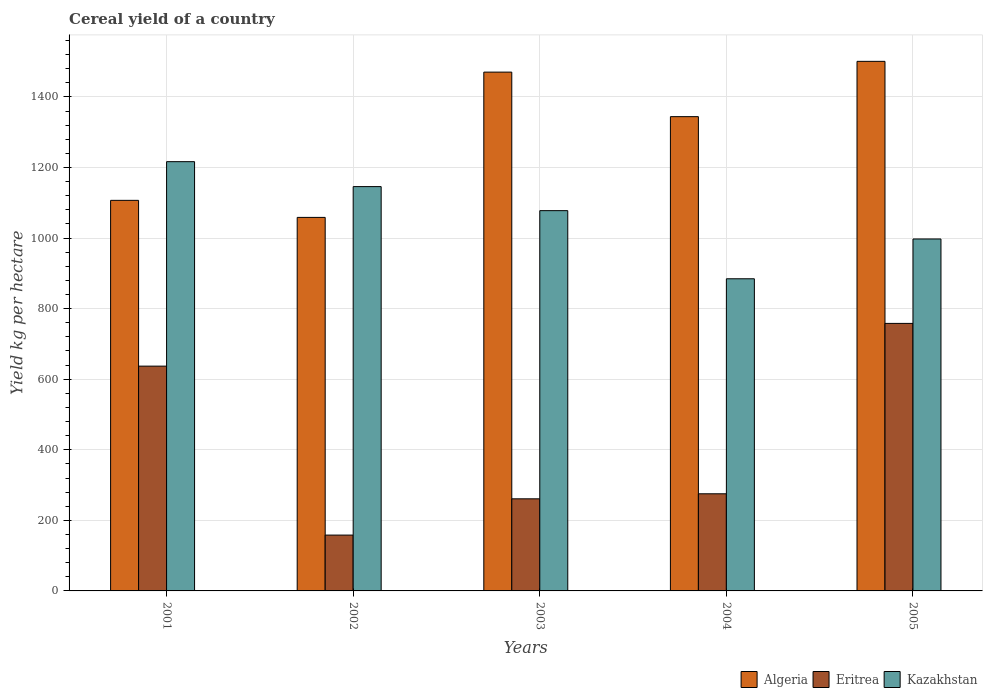How many different coloured bars are there?
Your answer should be very brief. 3. How many groups of bars are there?
Your answer should be compact. 5. Are the number of bars per tick equal to the number of legend labels?
Offer a terse response. Yes. Are the number of bars on each tick of the X-axis equal?
Offer a terse response. Yes. How many bars are there on the 4th tick from the left?
Provide a succinct answer. 3. How many bars are there on the 4th tick from the right?
Give a very brief answer. 3. What is the total cereal yield in Kazakhstan in 2001?
Ensure brevity in your answer.  1216.57. Across all years, what is the maximum total cereal yield in Eritrea?
Your response must be concise. 758.2. Across all years, what is the minimum total cereal yield in Algeria?
Your answer should be very brief. 1058.62. What is the total total cereal yield in Kazakhstan in the graph?
Keep it short and to the point. 5322.3. What is the difference between the total cereal yield in Algeria in 2002 and that in 2004?
Offer a terse response. -285.51. What is the difference between the total cereal yield in Kazakhstan in 2005 and the total cereal yield in Algeria in 2002?
Offer a terse response. -61.16. What is the average total cereal yield in Kazakhstan per year?
Provide a short and direct response. 1064.46. In the year 2004, what is the difference between the total cereal yield in Algeria and total cereal yield in Kazakhstan?
Ensure brevity in your answer.  459.47. What is the ratio of the total cereal yield in Kazakhstan in 2001 to that in 2004?
Offer a terse response. 1.38. Is the difference between the total cereal yield in Algeria in 2002 and 2003 greater than the difference between the total cereal yield in Kazakhstan in 2002 and 2003?
Keep it short and to the point. No. What is the difference between the highest and the second highest total cereal yield in Kazakhstan?
Ensure brevity in your answer.  70.68. What is the difference between the highest and the lowest total cereal yield in Algeria?
Offer a very short reply. 442.24. In how many years, is the total cereal yield in Kazakhstan greater than the average total cereal yield in Kazakhstan taken over all years?
Ensure brevity in your answer.  3. Is the sum of the total cereal yield in Eritrea in 2003 and 2004 greater than the maximum total cereal yield in Kazakhstan across all years?
Make the answer very short. No. What does the 2nd bar from the left in 2003 represents?
Provide a succinct answer. Eritrea. What does the 1st bar from the right in 2001 represents?
Your answer should be compact. Kazakhstan. Is it the case that in every year, the sum of the total cereal yield in Kazakhstan and total cereal yield in Eritrea is greater than the total cereal yield in Algeria?
Ensure brevity in your answer.  No. Are all the bars in the graph horizontal?
Give a very brief answer. No. How many years are there in the graph?
Your response must be concise. 5. Does the graph contain grids?
Keep it short and to the point. Yes. Where does the legend appear in the graph?
Ensure brevity in your answer.  Bottom right. How are the legend labels stacked?
Offer a terse response. Horizontal. What is the title of the graph?
Provide a succinct answer. Cereal yield of a country. What is the label or title of the X-axis?
Your answer should be compact. Years. What is the label or title of the Y-axis?
Offer a very short reply. Yield kg per hectare. What is the Yield kg per hectare in Algeria in 2001?
Give a very brief answer. 1106.92. What is the Yield kg per hectare in Eritrea in 2001?
Make the answer very short. 637.09. What is the Yield kg per hectare in Kazakhstan in 2001?
Keep it short and to the point. 1216.57. What is the Yield kg per hectare of Algeria in 2002?
Your response must be concise. 1058.62. What is the Yield kg per hectare of Eritrea in 2002?
Give a very brief answer. 158.23. What is the Yield kg per hectare of Kazakhstan in 2002?
Offer a terse response. 1145.89. What is the Yield kg per hectare of Algeria in 2003?
Provide a short and direct response. 1470.34. What is the Yield kg per hectare of Eritrea in 2003?
Ensure brevity in your answer.  261.04. What is the Yield kg per hectare in Kazakhstan in 2003?
Provide a succinct answer. 1077.73. What is the Yield kg per hectare of Algeria in 2004?
Offer a terse response. 1344.12. What is the Yield kg per hectare of Eritrea in 2004?
Offer a very short reply. 275.29. What is the Yield kg per hectare in Kazakhstan in 2004?
Offer a terse response. 884.65. What is the Yield kg per hectare of Algeria in 2005?
Offer a terse response. 1500.85. What is the Yield kg per hectare of Eritrea in 2005?
Offer a terse response. 758.2. What is the Yield kg per hectare of Kazakhstan in 2005?
Your answer should be compact. 997.45. Across all years, what is the maximum Yield kg per hectare of Algeria?
Offer a very short reply. 1500.85. Across all years, what is the maximum Yield kg per hectare in Eritrea?
Offer a terse response. 758.2. Across all years, what is the maximum Yield kg per hectare in Kazakhstan?
Keep it short and to the point. 1216.57. Across all years, what is the minimum Yield kg per hectare in Algeria?
Make the answer very short. 1058.62. Across all years, what is the minimum Yield kg per hectare in Eritrea?
Offer a terse response. 158.23. Across all years, what is the minimum Yield kg per hectare of Kazakhstan?
Ensure brevity in your answer.  884.65. What is the total Yield kg per hectare of Algeria in the graph?
Offer a very short reply. 6480.85. What is the total Yield kg per hectare in Eritrea in the graph?
Your answer should be very brief. 2089.84. What is the total Yield kg per hectare in Kazakhstan in the graph?
Your answer should be very brief. 5322.3. What is the difference between the Yield kg per hectare in Algeria in 2001 and that in 2002?
Offer a very short reply. 48.3. What is the difference between the Yield kg per hectare in Eritrea in 2001 and that in 2002?
Make the answer very short. 478.86. What is the difference between the Yield kg per hectare in Kazakhstan in 2001 and that in 2002?
Offer a very short reply. 70.68. What is the difference between the Yield kg per hectare in Algeria in 2001 and that in 2003?
Your response must be concise. -363.43. What is the difference between the Yield kg per hectare in Eritrea in 2001 and that in 2003?
Your response must be concise. 376.05. What is the difference between the Yield kg per hectare in Kazakhstan in 2001 and that in 2003?
Provide a short and direct response. 138.84. What is the difference between the Yield kg per hectare in Algeria in 2001 and that in 2004?
Your answer should be very brief. -237.21. What is the difference between the Yield kg per hectare of Eritrea in 2001 and that in 2004?
Make the answer very short. 361.8. What is the difference between the Yield kg per hectare in Kazakhstan in 2001 and that in 2004?
Your answer should be very brief. 331.92. What is the difference between the Yield kg per hectare in Algeria in 2001 and that in 2005?
Your response must be concise. -393.94. What is the difference between the Yield kg per hectare of Eritrea in 2001 and that in 2005?
Offer a very short reply. -121.11. What is the difference between the Yield kg per hectare in Kazakhstan in 2001 and that in 2005?
Offer a terse response. 219.12. What is the difference between the Yield kg per hectare in Algeria in 2002 and that in 2003?
Your answer should be compact. -411.73. What is the difference between the Yield kg per hectare of Eritrea in 2002 and that in 2003?
Your answer should be very brief. -102.81. What is the difference between the Yield kg per hectare in Kazakhstan in 2002 and that in 2003?
Your answer should be compact. 68.16. What is the difference between the Yield kg per hectare in Algeria in 2002 and that in 2004?
Your response must be concise. -285.51. What is the difference between the Yield kg per hectare of Eritrea in 2002 and that in 2004?
Your answer should be compact. -117.06. What is the difference between the Yield kg per hectare in Kazakhstan in 2002 and that in 2004?
Offer a very short reply. 261.23. What is the difference between the Yield kg per hectare in Algeria in 2002 and that in 2005?
Provide a succinct answer. -442.24. What is the difference between the Yield kg per hectare of Eritrea in 2002 and that in 2005?
Ensure brevity in your answer.  -599.97. What is the difference between the Yield kg per hectare in Kazakhstan in 2002 and that in 2005?
Ensure brevity in your answer.  148.44. What is the difference between the Yield kg per hectare of Algeria in 2003 and that in 2004?
Your answer should be very brief. 126.22. What is the difference between the Yield kg per hectare in Eritrea in 2003 and that in 2004?
Offer a very short reply. -14.25. What is the difference between the Yield kg per hectare in Kazakhstan in 2003 and that in 2004?
Your response must be concise. 193.08. What is the difference between the Yield kg per hectare in Algeria in 2003 and that in 2005?
Ensure brevity in your answer.  -30.51. What is the difference between the Yield kg per hectare in Eritrea in 2003 and that in 2005?
Your answer should be very brief. -497.16. What is the difference between the Yield kg per hectare of Kazakhstan in 2003 and that in 2005?
Keep it short and to the point. 80.28. What is the difference between the Yield kg per hectare in Algeria in 2004 and that in 2005?
Your response must be concise. -156.73. What is the difference between the Yield kg per hectare of Eritrea in 2004 and that in 2005?
Your answer should be compact. -482.91. What is the difference between the Yield kg per hectare of Kazakhstan in 2004 and that in 2005?
Keep it short and to the point. -112.8. What is the difference between the Yield kg per hectare of Algeria in 2001 and the Yield kg per hectare of Eritrea in 2002?
Provide a short and direct response. 948.69. What is the difference between the Yield kg per hectare in Algeria in 2001 and the Yield kg per hectare in Kazakhstan in 2002?
Your answer should be compact. -38.97. What is the difference between the Yield kg per hectare of Eritrea in 2001 and the Yield kg per hectare of Kazakhstan in 2002?
Offer a very short reply. -508.8. What is the difference between the Yield kg per hectare of Algeria in 2001 and the Yield kg per hectare of Eritrea in 2003?
Your response must be concise. 845.88. What is the difference between the Yield kg per hectare in Algeria in 2001 and the Yield kg per hectare in Kazakhstan in 2003?
Give a very brief answer. 29.18. What is the difference between the Yield kg per hectare of Eritrea in 2001 and the Yield kg per hectare of Kazakhstan in 2003?
Make the answer very short. -440.64. What is the difference between the Yield kg per hectare in Algeria in 2001 and the Yield kg per hectare in Eritrea in 2004?
Make the answer very short. 831.63. What is the difference between the Yield kg per hectare of Algeria in 2001 and the Yield kg per hectare of Kazakhstan in 2004?
Ensure brevity in your answer.  222.26. What is the difference between the Yield kg per hectare in Eritrea in 2001 and the Yield kg per hectare in Kazakhstan in 2004?
Your answer should be very brief. -247.56. What is the difference between the Yield kg per hectare of Algeria in 2001 and the Yield kg per hectare of Eritrea in 2005?
Make the answer very short. 348.72. What is the difference between the Yield kg per hectare in Algeria in 2001 and the Yield kg per hectare in Kazakhstan in 2005?
Offer a very short reply. 109.46. What is the difference between the Yield kg per hectare of Eritrea in 2001 and the Yield kg per hectare of Kazakhstan in 2005?
Make the answer very short. -360.36. What is the difference between the Yield kg per hectare in Algeria in 2002 and the Yield kg per hectare in Eritrea in 2003?
Provide a succinct answer. 797.58. What is the difference between the Yield kg per hectare in Algeria in 2002 and the Yield kg per hectare in Kazakhstan in 2003?
Your answer should be compact. -19.11. What is the difference between the Yield kg per hectare in Eritrea in 2002 and the Yield kg per hectare in Kazakhstan in 2003?
Keep it short and to the point. -919.5. What is the difference between the Yield kg per hectare of Algeria in 2002 and the Yield kg per hectare of Eritrea in 2004?
Keep it short and to the point. 783.33. What is the difference between the Yield kg per hectare of Algeria in 2002 and the Yield kg per hectare of Kazakhstan in 2004?
Make the answer very short. 173.96. What is the difference between the Yield kg per hectare of Eritrea in 2002 and the Yield kg per hectare of Kazakhstan in 2004?
Keep it short and to the point. -726.42. What is the difference between the Yield kg per hectare of Algeria in 2002 and the Yield kg per hectare of Eritrea in 2005?
Keep it short and to the point. 300.42. What is the difference between the Yield kg per hectare of Algeria in 2002 and the Yield kg per hectare of Kazakhstan in 2005?
Give a very brief answer. 61.16. What is the difference between the Yield kg per hectare in Eritrea in 2002 and the Yield kg per hectare in Kazakhstan in 2005?
Your response must be concise. -839.22. What is the difference between the Yield kg per hectare in Algeria in 2003 and the Yield kg per hectare in Eritrea in 2004?
Give a very brief answer. 1195.05. What is the difference between the Yield kg per hectare in Algeria in 2003 and the Yield kg per hectare in Kazakhstan in 2004?
Keep it short and to the point. 585.69. What is the difference between the Yield kg per hectare in Eritrea in 2003 and the Yield kg per hectare in Kazakhstan in 2004?
Ensure brevity in your answer.  -623.62. What is the difference between the Yield kg per hectare in Algeria in 2003 and the Yield kg per hectare in Eritrea in 2005?
Your response must be concise. 712.15. What is the difference between the Yield kg per hectare of Algeria in 2003 and the Yield kg per hectare of Kazakhstan in 2005?
Provide a succinct answer. 472.89. What is the difference between the Yield kg per hectare in Eritrea in 2003 and the Yield kg per hectare in Kazakhstan in 2005?
Your answer should be compact. -736.42. What is the difference between the Yield kg per hectare of Algeria in 2004 and the Yield kg per hectare of Eritrea in 2005?
Keep it short and to the point. 585.93. What is the difference between the Yield kg per hectare in Algeria in 2004 and the Yield kg per hectare in Kazakhstan in 2005?
Keep it short and to the point. 346.67. What is the difference between the Yield kg per hectare in Eritrea in 2004 and the Yield kg per hectare in Kazakhstan in 2005?
Provide a short and direct response. -722.16. What is the average Yield kg per hectare of Algeria per year?
Offer a terse response. 1296.17. What is the average Yield kg per hectare of Eritrea per year?
Ensure brevity in your answer.  417.97. What is the average Yield kg per hectare in Kazakhstan per year?
Make the answer very short. 1064.46. In the year 2001, what is the difference between the Yield kg per hectare of Algeria and Yield kg per hectare of Eritrea?
Offer a very short reply. 469.83. In the year 2001, what is the difference between the Yield kg per hectare in Algeria and Yield kg per hectare in Kazakhstan?
Provide a short and direct response. -109.66. In the year 2001, what is the difference between the Yield kg per hectare in Eritrea and Yield kg per hectare in Kazakhstan?
Keep it short and to the point. -579.48. In the year 2002, what is the difference between the Yield kg per hectare of Algeria and Yield kg per hectare of Eritrea?
Give a very brief answer. 900.39. In the year 2002, what is the difference between the Yield kg per hectare of Algeria and Yield kg per hectare of Kazakhstan?
Offer a terse response. -87.27. In the year 2002, what is the difference between the Yield kg per hectare of Eritrea and Yield kg per hectare of Kazakhstan?
Your answer should be compact. -987.66. In the year 2003, what is the difference between the Yield kg per hectare in Algeria and Yield kg per hectare in Eritrea?
Offer a terse response. 1209.31. In the year 2003, what is the difference between the Yield kg per hectare in Algeria and Yield kg per hectare in Kazakhstan?
Offer a terse response. 392.61. In the year 2003, what is the difference between the Yield kg per hectare in Eritrea and Yield kg per hectare in Kazakhstan?
Your answer should be compact. -816.7. In the year 2004, what is the difference between the Yield kg per hectare in Algeria and Yield kg per hectare in Eritrea?
Offer a terse response. 1068.83. In the year 2004, what is the difference between the Yield kg per hectare of Algeria and Yield kg per hectare of Kazakhstan?
Provide a short and direct response. 459.47. In the year 2004, what is the difference between the Yield kg per hectare of Eritrea and Yield kg per hectare of Kazakhstan?
Give a very brief answer. -609.36. In the year 2005, what is the difference between the Yield kg per hectare in Algeria and Yield kg per hectare in Eritrea?
Provide a short and direct response. 742.65. In the year 2005, what is the difference between the Yield kg per hectare of Algeria and Yield kg per hectare of Kazakhstan?
Your response must be concise. 503.4. In the year 2005, what is the difference between the Yield kg per hectare of Eritrea and Yield kg per hectare of Kazakhstan?
Your answer should be compact. -239.26. What is the ratio of the Yield kg per hectare in Algeria in 2001 to that in 2002?
Offer a very short reply. 1.05. What is the ratio of the Yield kg per hectare of Eritrea in 2001 to that in 2002?
Provide a succinct answer. 4.03. What is the ratio of the Yield kg per hectare of Kazakhstan in 2001 to that in 2002?
Give a very brief answer. 1.06. What is the ratio of the Yield kg per hectare in Algeria in 2001 to that in 2003?
Your answer should be very brief. 0.75. What is the ratio of the Yield kg per hectare of Eritrea in 2001 to that in 2003?
Make the answer very short. 2.44. What is the ratio of the Yield kg per hectare in Kazakhstan in 2001 to that in 2003?
Offer a terse response. 1.13. What is the ratio of the Yield kg per hectare of Algeria in 2001 to that in 2004?
Your answer should be very brief. 0.82. What is the ratio of the Yield kg per hectare in Eritrea in 2001 to that in 2004?
Ensure brevity in your answer.  2.31. What is the ratio of the Yield kg per hectare in Kazakhstan in 2001 to that in 2004?
Make the answer very short. 1.38. What is the ratio of the Yield kg per hectare of Algeria in 2001 to that in 2005?
Your answer should be very brief. 0.74. What is the ratio of the Yield kg per hectare of Eritrea in 2001 to that in 2005?
Keep it short and to the point. 0.84. What is the ratio of the Yield kg per hectare in Kazakhstan in 2001 to that in 2005?
Offer a very short reply. 1.22. What is the ratio of the Yield kg per hectare of Algeria in 2002 to that in 2003?
Provide a succinct answer. 0.72. What is the ratio of the Yield kg per hectare of Eritrea in 2002 to that in 2003?
Offer a terse response. 0.61. What is the ratio of the Yield kg per hectare in Kazakhstan in 2002 to that in 2003?
Offer a very short reply. 1.06. What is the ratio of the Yield kg per hectare of Algeria in 2002 to that in 2004?
Your answer should be compact. 0.79. What is the ratio of the Yield kg per hectare of Eritrea in 2002 to that in 2004?
Provide a short and direct response. 0.57. What is the ratio of the Yield kg per hectare in Kazakhstan in 2002 to that in 2004?
Offer a terse response. 1.3. What is the ratio of the Yield kg per hectare of Algeria in 2002 to that in 2005?
Ensure brevity in your answer.  0.71. What is the ratio of the Yield kg per hectare in Eritrea in 2002 to that in 2005?
Offer a very short reply. 0.21. What is the ratio of the Yield kg per hectare in Kazakhstan in 2002 to that in 2005?
Give a very brief answer. 1.15. What is the ratio of the Yield kg per hectare in Algeria in 2003 to that in 2004?
Keep it short and to the point. 1.09. What is the ratio of the Yield kg per hectare of Eritrea in 2003 to that in 2004?
Keep it short and to the point. 0.95. What is the ratio of the Yield kg per hectare in Kazakhstan in 2003 to that in 2004?
Keep it short and to the point. 1.22. What is the ratio of the Yield kg per hectare in Algeria in 2003 to that in 2005?
Offer a very short reply. 0.98. What is the ratio of the Yield kg per hectare in Eritrea in 2003 to that in 2005?
Provide a succinct answer. 0.34. What is the ratio of the Yield kg per hectare of Kazakhstan in 2003 to that in 2005?
Your answer should be very brief. 1.08. What is the ratio of the Yield kg per hectare of Algeria in 2004 to that in 2005?
Your answer should be compact. 0.9. What is the ratio of the Yield kg per hectare in Eritrea in 2004 to that in 2005?
Ensure brevity in your answer.  0.36. What is the ratio of the Yield kg per hectare in Kazakhstan in 2004 to that in 2005?
Your answer should be very brief. 0.89. What is the difference between the highest and the second highest Yield kg per hectare in Algeria?
Offer a very short reply. 30.51. What is the difference between the highest and the second highest Yield kg per hectare in Eritrea?
Your answer should be very brief. 121.11. What is the difference between the highest and the second highest Yield kg per hectare in Kazakhstan?
Offer a very short reply. 70.68. What is the difference between the highest and the lowest Yield kg per hectare in Algeria?
Your response must be concise. 442.24. What is the difference between the highest and the lowest Yield kg per hectare in Eritrea?
Offer a very short reply. 599.97. What is the difference between the highest and the lowest Yield kg per hectare of Kazakhstan?
Make the answer very short. 331.92. 